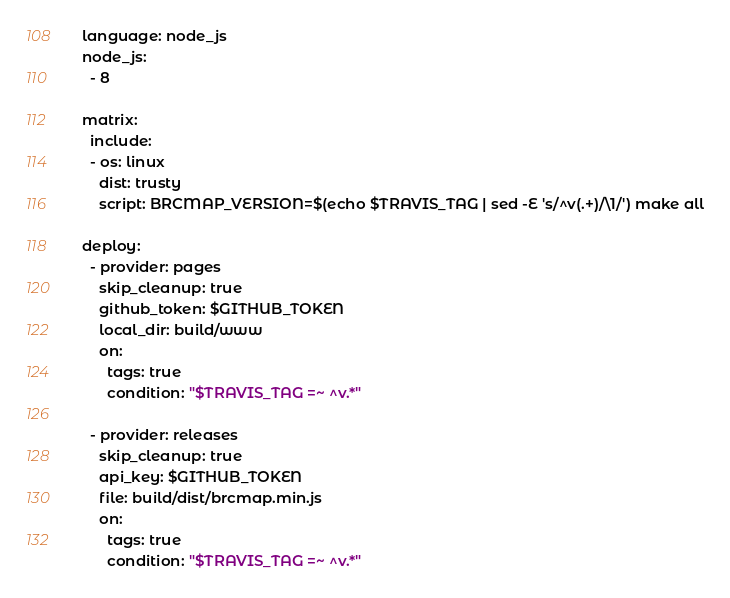Convert code to text. <code><loc_0><loc_0><loc_500><loc_500><_YAML_>language: node_js
node_js:
  - 8

matrix:
  include:
  - os: linux
    dist: trusty
    script: BRCMAP_VERSION=$(echo $TRAVIS_TAG | sed -E 's/^v(.+)/\1/') make all

deploy:
  - provider: pages
    skip_cleanup: true
    github_token: $GITHUB_TOKEN
    local_dir: build/www
    on:
      tags: true
      condition: "$TRAVIS_TAG =~ ^v.*"
  
  - provider: releases
    skip_cleanup: true
    api_key: $GITHUB_TOKEN
    file: build/dist/brcmap.min.js
    on:
      tags: true
      condition: "$TRAVIS_TAG =~ ^v.*"
</code> 